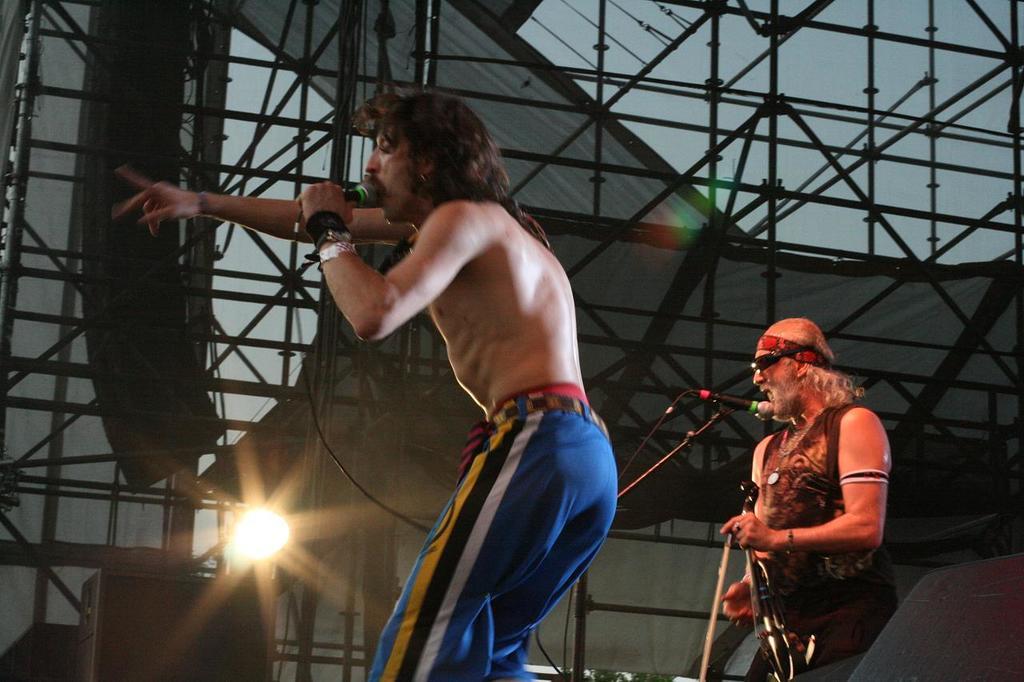In one or two sentences, can you explain what this image depicts? In this image there is a man standing on the stage and singing with the mic. In the background there are iron rods. On the right side there is another man who is standing in front of the mic. On the left side there is a light. 